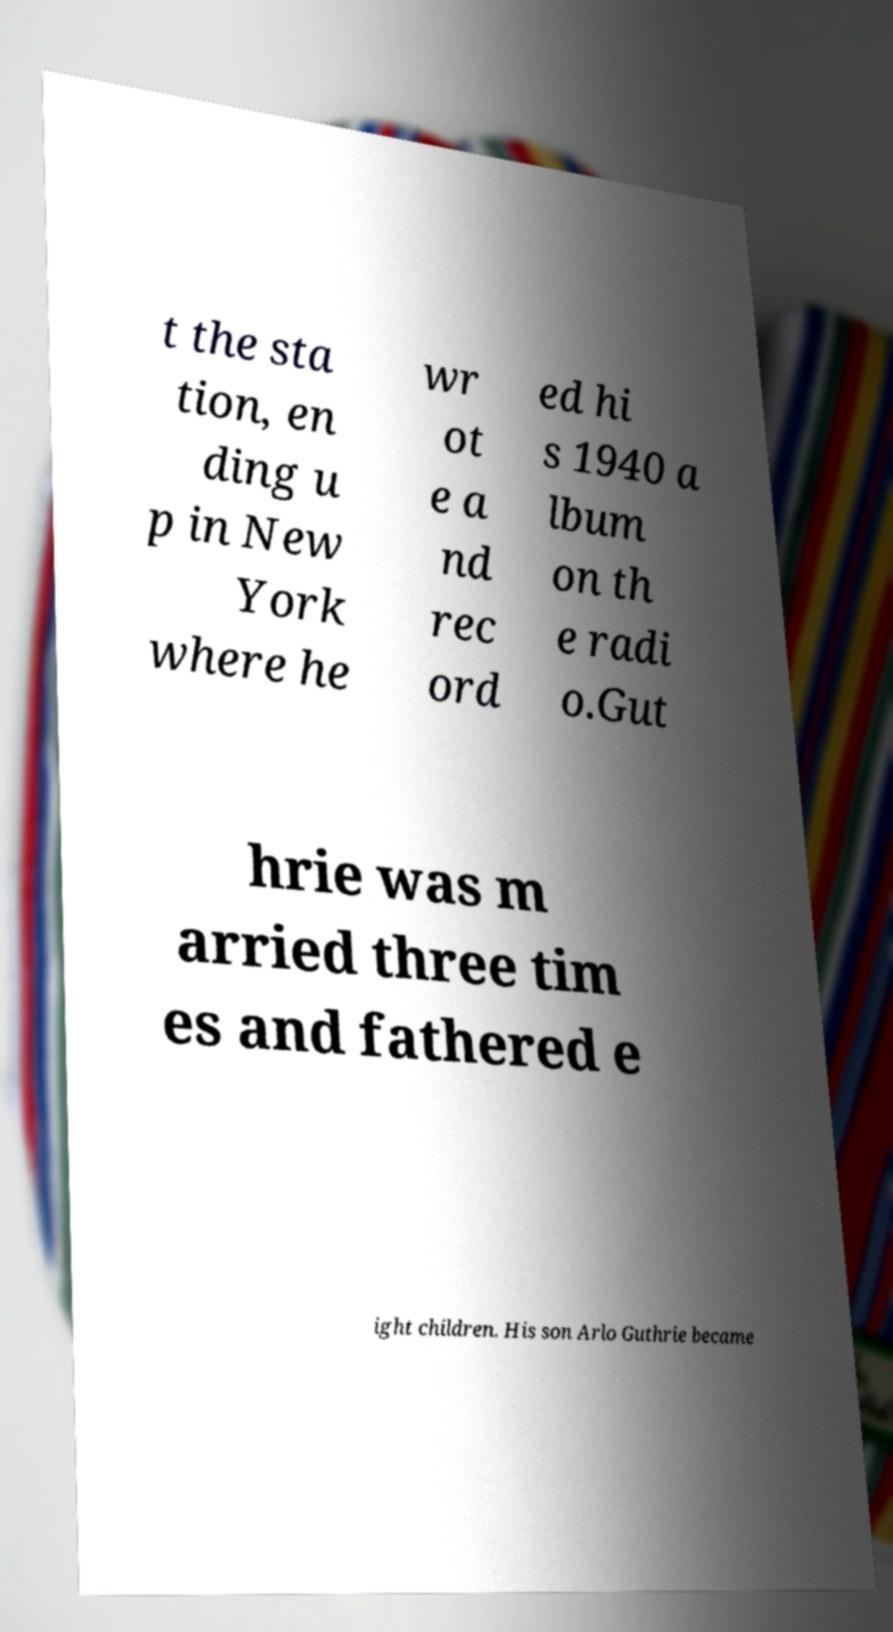Could you extract and type out the text from this image? t the sta tion, en ding u p in New York where he wr ot e a nd rec ord ed hi s 1940 a lbum on th e radi o.Gut hrie was m arried three tim es and fathered e ight children. His son Arlo Guthrie became 